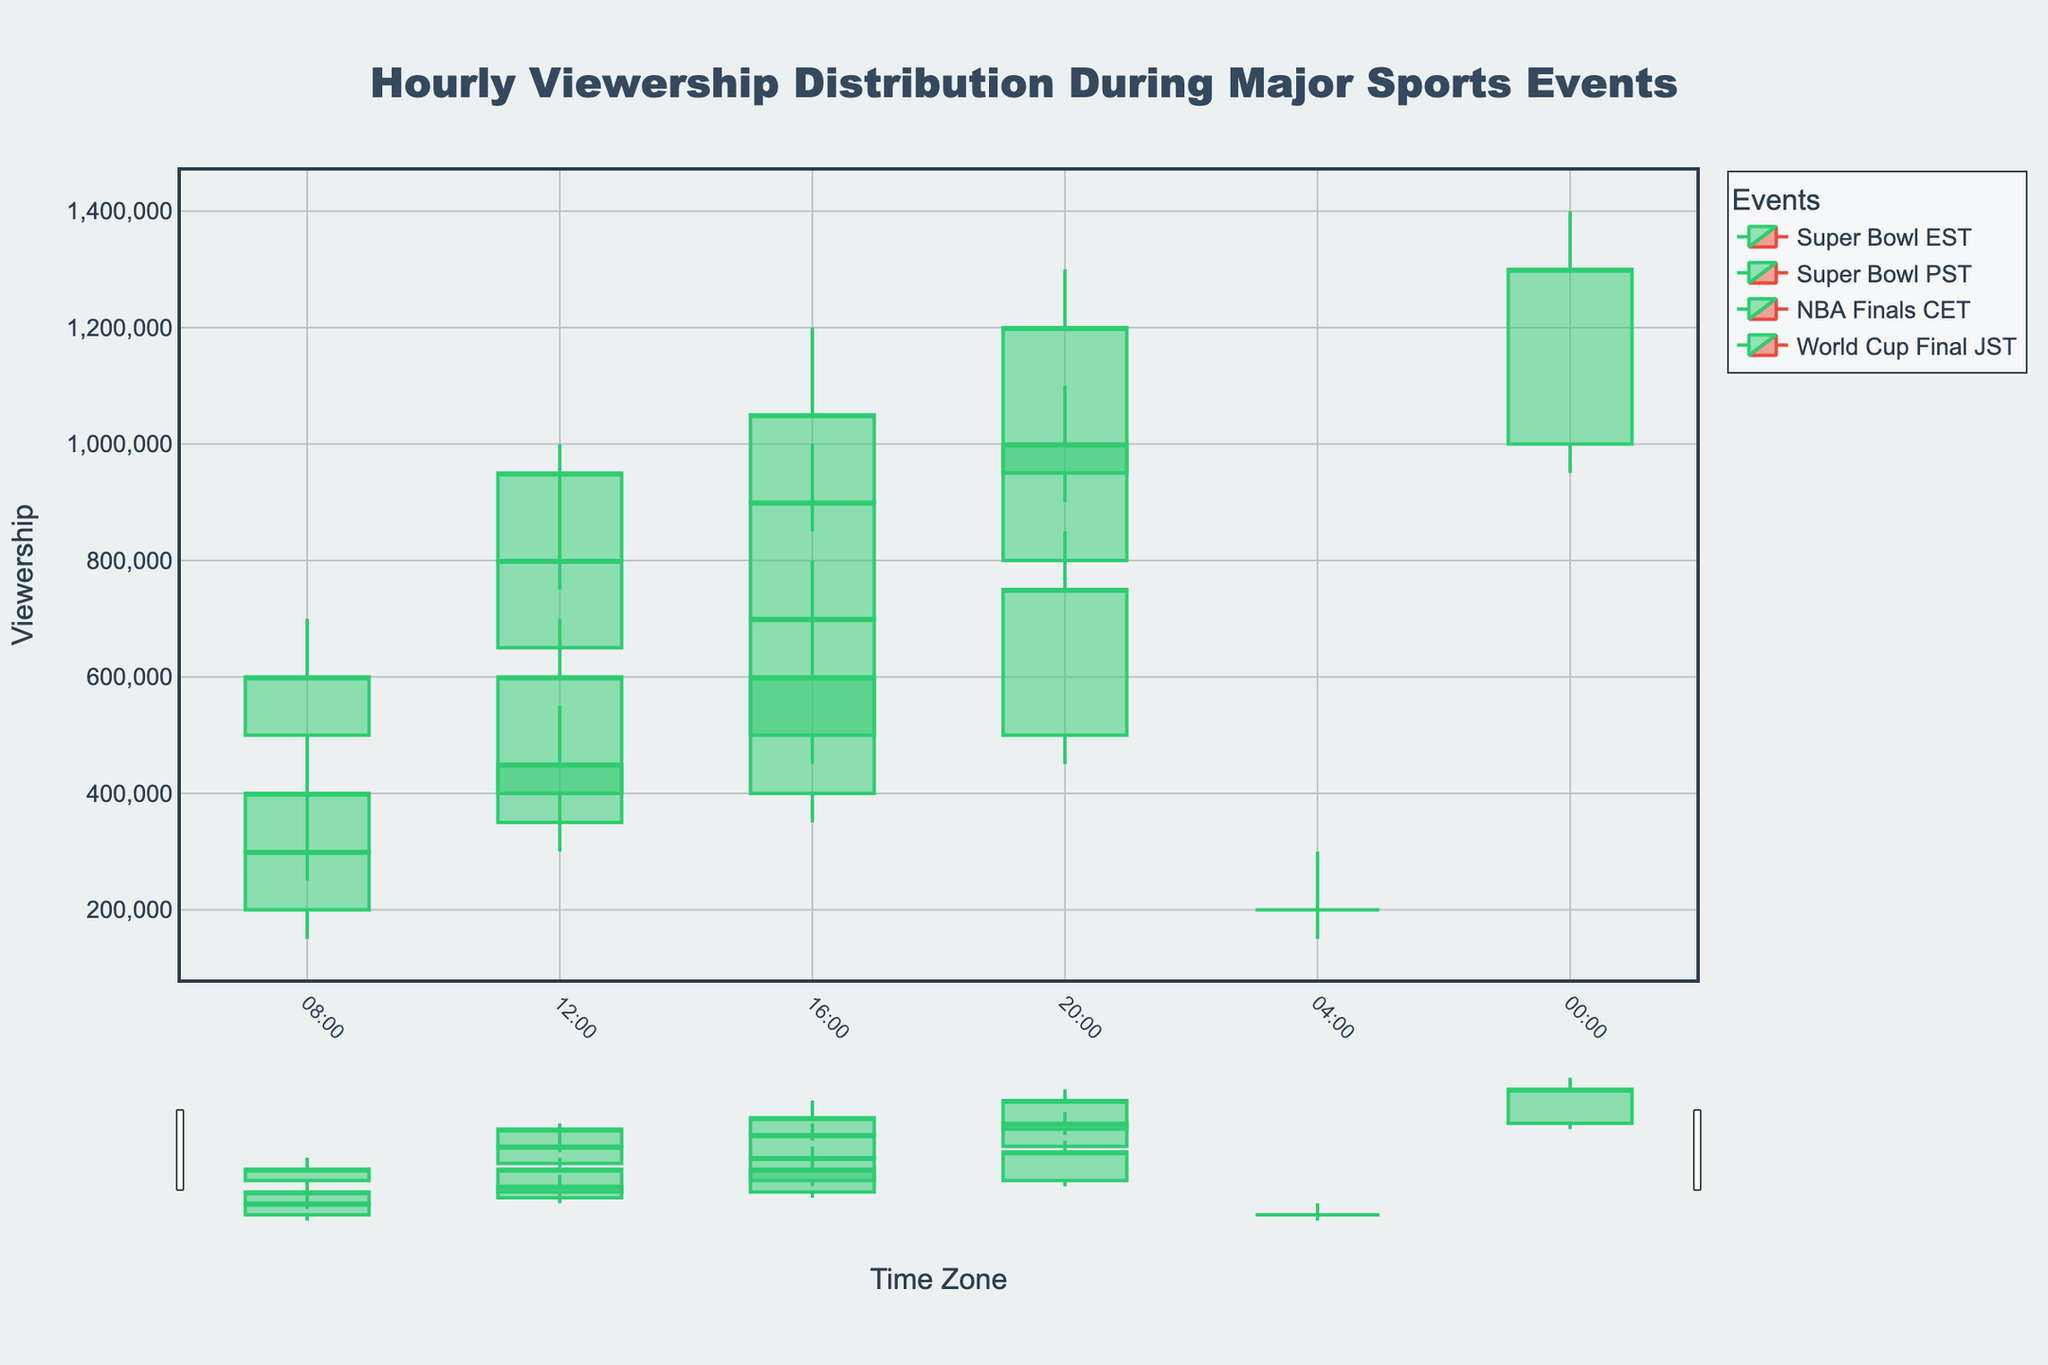What's the title of the plot? The title of the plot is located at the top center of the figure. It reads "Hourly Viewership Distribution During Major Sports Events."
Answer: Hourly Viewership Distribution During Major Sports Events What is the y-axis title? The y-axis title is given on the left side of the plot and it is labeled "Viewership."
Answer: Viewership Which event had the highest viewership in the EST time zone? To determine which event had the highest viewership, we look at the candlestick with the highest "High" value within the EST time zone. For the "Super Bowl EST" at 20:00, the high value was 1,100,000 which is the highest.
Answer: Super Bowl EST At what time did the Super Bowl in the PST time zone have the highest close value? In the PST time zone, we look at the candlestick plot for "Close" values of "Super Bowl PST." The highest close value in this series is 750,000 at 20:00.
Answer: 20:00 Which event had the lowest viewership in the CET time zone according to the Low values? To find the event with the lowest "Low" value in CET, check the candlesticks under "NBA Finals CET." The lowest low value is 150,000 at 04:00.
Answer: NBA Finals CET How does the viewership peak of the World Cup Finals compare in the JST time zone to the peak of the Super Bowl in the EST time zone? For comparison, look at the highest "High" values for each event. The "World Cup Final JST" has a peak of 1,400,000 at 00:00, while the "Super Bowl EST" peaks at 1,100,000 at 20:00. The World Cup Final in JST has a higher peak.
Answer: The World Cup Final in JST What is the average closing viewership for the Super Bowl in the EST time zone? Sum the "Close" values for the "Super Bowl EST" (600,000 + 800,000 + 900,000 + 1,000,000 = 3,300,000) and divide by the number of data points (4). So, the average is 3,300,000 / 4.
Answer: 825,000 How much did the viewership vary within the World Cup Final at 12:00 JST? Viewership variance is calculated as the difference between the "High" and "Low" values for "World Cup Final JST" at 12:00. The difference is 1,000,000 - 750,000.
Answer: 250,000 Which event had the most stable viewership in terms of the smallest range in closing values? Calculate the range (difference between highest and lowest Close values) for each event, and check which one is smallest. "NBA Finals CET" has Close values of 200,000, 400,000, 600,000, 700,000, whose range is 700,000 - 200,000 = 500,000. No other event has a smaller range.
Answer: NBA Finals CET 